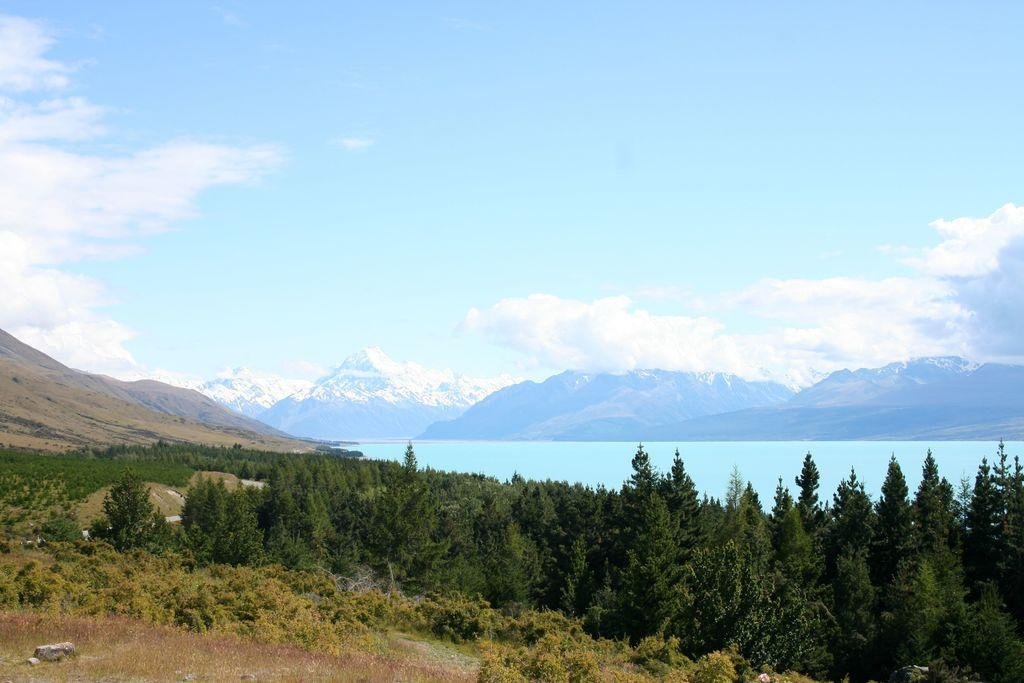What type of natural features can be seen in the image? There are trees, mountains, and water visible in the image. What part of the natural environment is visible in the sky? The sky is visible in the image. Can you describe the setting where the image might have been taken? The image may have been taken near the mountains, as they are a prominent feature in the image. What type of crack can be seen in the image? There is no crack present in the image. What type of honey can be seen dripping from the trees in the image? There is no honey present in the image; it features trees, mountains, water, and the sky. 